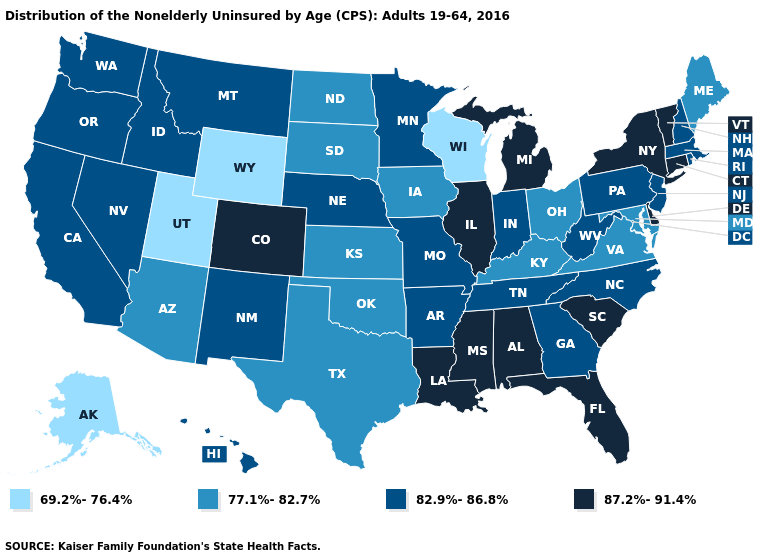Does Maryland have the same value as Maine?
Write a very short answer. Yes. How many symbols are there in the legend?
Short answer required. 4. Name the states that have a value in the range 69.2%-76.4%?
Quick response, please. Alaska, Utah, Wisconsin, Wyoming. Among the states that border Pennsylvania , which have the highest value?
Give a very brief answer. Delaware, New York. What is the value of Arizona?
Be succinct. 77.1%-82.7%. Among the states that border New Jersey , does Delaware have the lowest value?
Keep it brief. No. Does Utah have the highest value in the West?
Be succinct. No. Does the map have missing data?
Write a very short answer. No. What is the value of Vermont?
Concise answer only. 87.2%-91.4%. Name the states that have a value in the range 69.2%-76.4%?
Be succinct. Alaska, Utah, Wisconsin, Wyoming. What is the value of Nebraska?
Short answer required. 82.9%-86.8%. Name the states that have a value in the range 69.2%-76.4%?
Give a very brief answer. Alaska, Utah, Wisconsin, Wyoming. What is the value of Missouri?
Keep it brief. 82.9%-86.8%. Among the states that border Michigan , does Indiana have the highest value?
Quick response, please. Yes. Name the states that have a value in the range 69.2%-76.4%?
Concise answer only. Alaska, Utah, Wisconsin, Wyoming. 